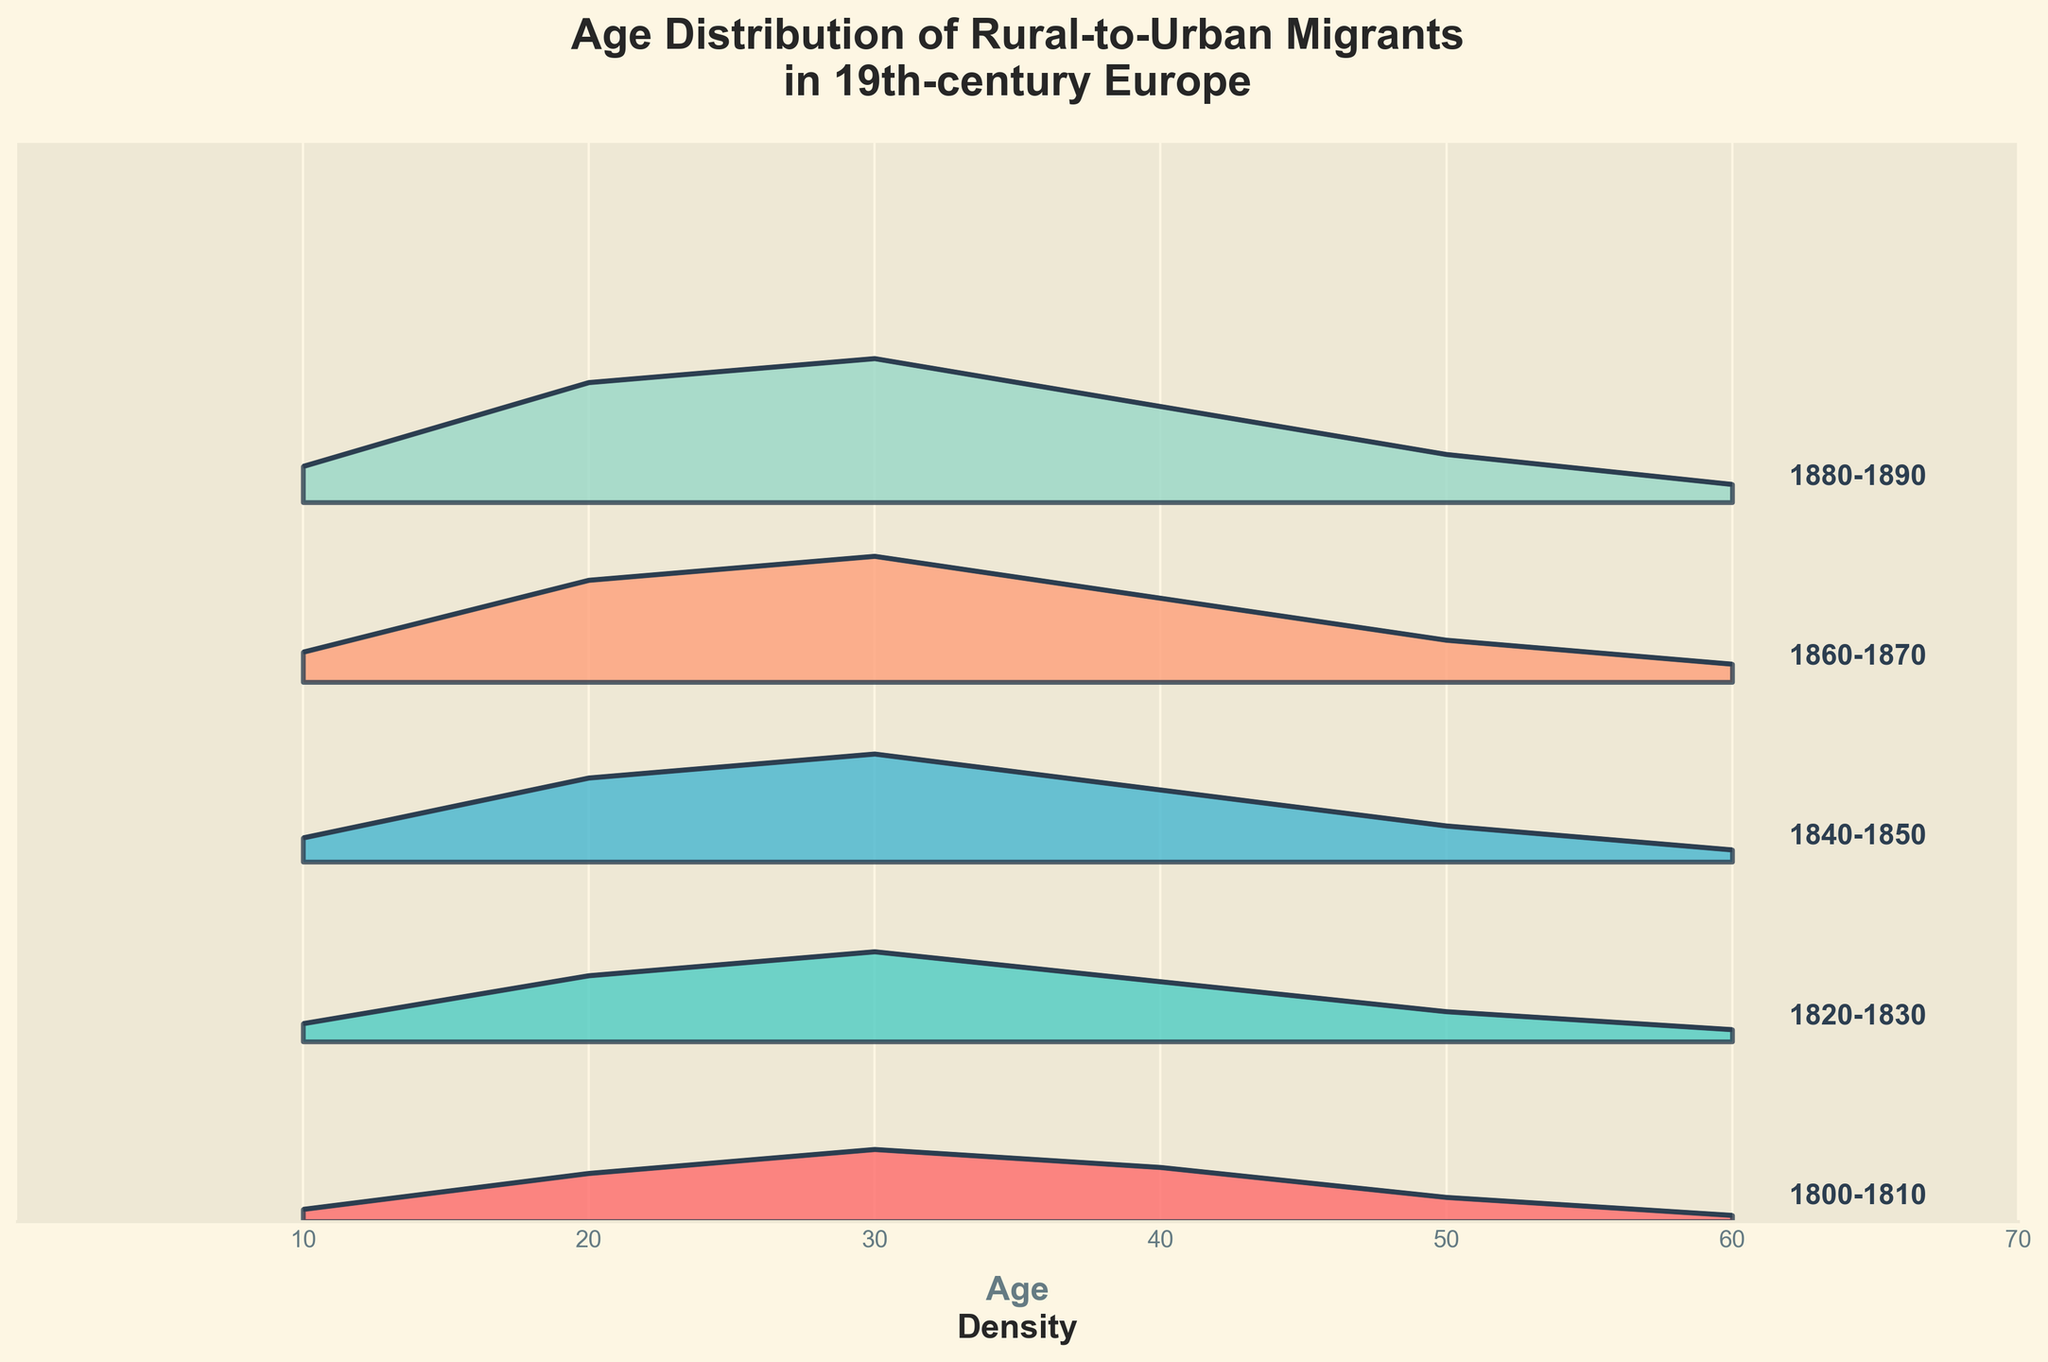What's the title of the figure? The title of the figure is displayed at the top, formatted in a larger and bold font.
Answer: Age Distribution of Rural-to-Urban Migrants in 19th-century Europe What are the x-axis labels representing? The labels along the x-axis indicate the age groups of the migrants, with numbers at regular intervals from 0 to 70.
Answer: Age How does the density of migrants in the 30s age group compare across different decades? To compare, observe the height of the plots at age 30 for each decade. The density increases from 0.12 in the 1800-1810 decade, to 0.15 in 1820-1830, 0.18 in 1840-1850, 0.21 in 1860-1870, and peaks at 0.24 in 1880-1890.
Answer: It increases progressively In which decade is the density of migrants aged 20 highest? Look at the heights of the plots at age 20 across different decades; the 1880-1890 plot is the highest at 0.20.
Answer: 1880-1890 Which decade shows the lowest density for migrants aged 50? Compare plot heights at age 50. The lowest is the 1800-1810 decade with a density of 0.04.
Answer: 1800-1810 How has the peak density of migrants in their 40s changed over the decades? Examine the height of the plots at age 40: 0.09 in 1800-1810, 0.10 in 1820-1830, 0.12 in 1840-1850, 0.14 in 1860-1870, and 0.16 in 1880-1890; the peak has gradually increased.
Answer: It increased steadily Which age group shows the maximum density in the 1840-1850 decade? Identify the age group in the 1840-1850 plot with the greatest height, which is age 30 with a density of 0.18.
Answer: 30 Which color is used for the decade 1860-1870, and where is it located in the plot? The colors are assigned to the decades with a custom colormap. The color for 1860-1870 is likely a blend of blue and green hues, located towards the middle part of the plot.
Answer: A shade of blue-green Is the density stable across all ages within each decade? Review each decade's plot; none have a stable line across all ages. Differences in heights at ages suggest variations in density within decades.
Answer: No Which decade exhibits the smallest variation in migrant density across ages? Evaluate the range of density by the difference between peak and lowest points within each decade. The 1800-1810 decade, varying from 0.01 to 0.12, shows relatively smaller variation compared to others.
Answer: 1800-1810 